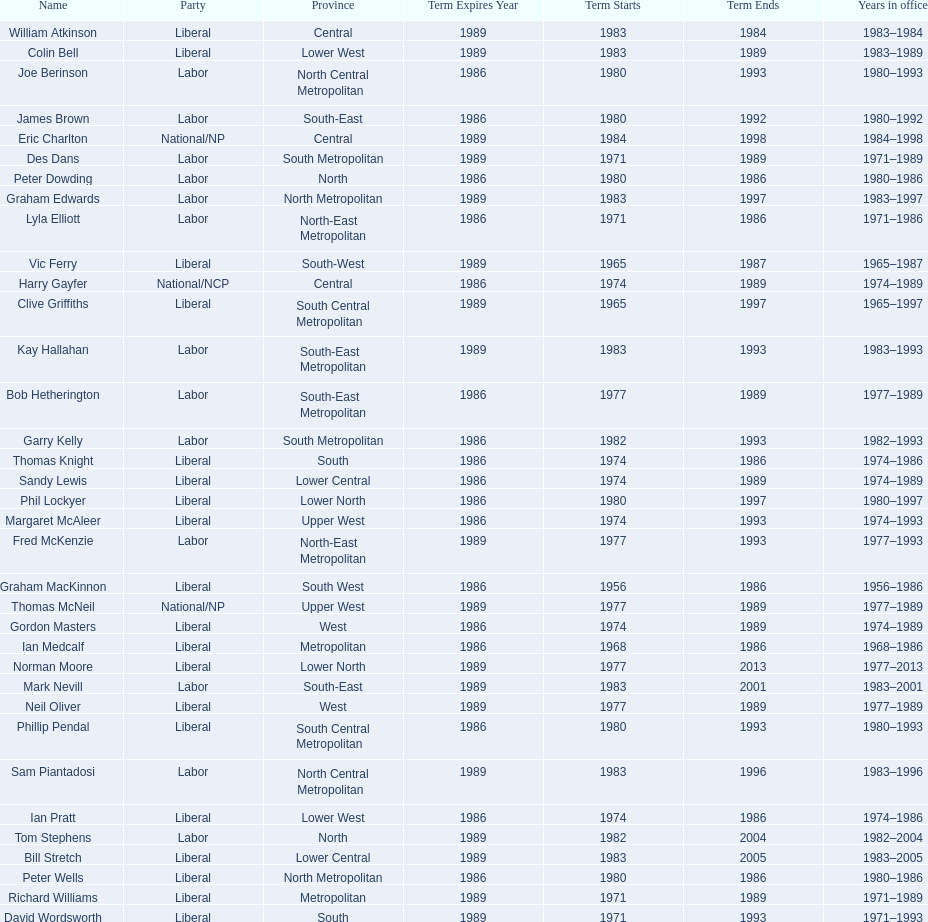Which party has the most membership? Liberal. 